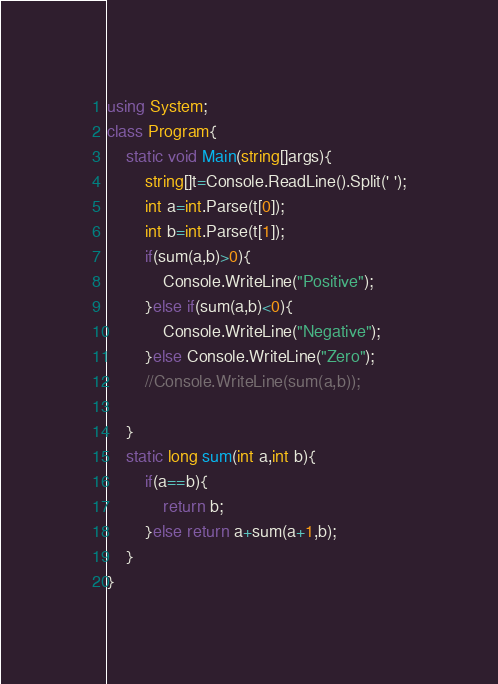Convert code to text. <code><loc_0><loc_0><loc_500><loc_500><_C#_>using System;
class Program{
    static void Main(string[]args){
        string[]t=Console.ReadLine().Split(' ');
        int a=int.Parse(t[0]);
        int b=int.Parse(t[1]);
        if(sum(a,b)>0){
            Console.WriteLine("Positive");
        }else if(sum(a,b)<0){
            Console.WriteLine("Negative");
        }else Console.WriteLine("Zero");
        //Console.WriteLine(sum(a,b));

    }
    static long sum(int a,int b){
        if(a==b){
            return b;
        }else return a+sum(a+1,b);
    }
}</code> 